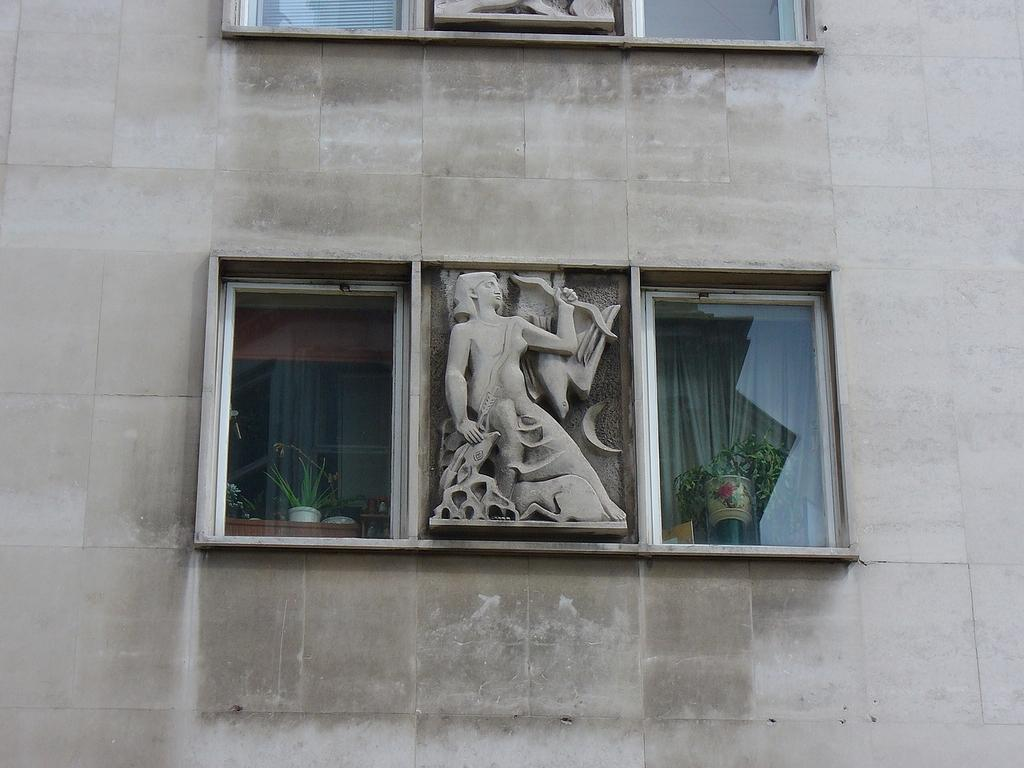What is present on the wall in the image? There is a wall in the image. How many glass windows are visible in the image? There are two glass windows in the image. What is located in the middle of the image? There is a sculpture in the middle of the image. What can be seen through the glass windows? Plants are visible through the glass windows. What type of window treatment is associated with the glass windows? Curtains are associated with the glass windows. What type of butter is being used to create the sculpture in the image? There is no butter present in the image; it features a sculpture made of a different material. What thoughts are being expressed by the plants visible through the glass windows? The plants do not express thoughts, as they are inanimate objects. 